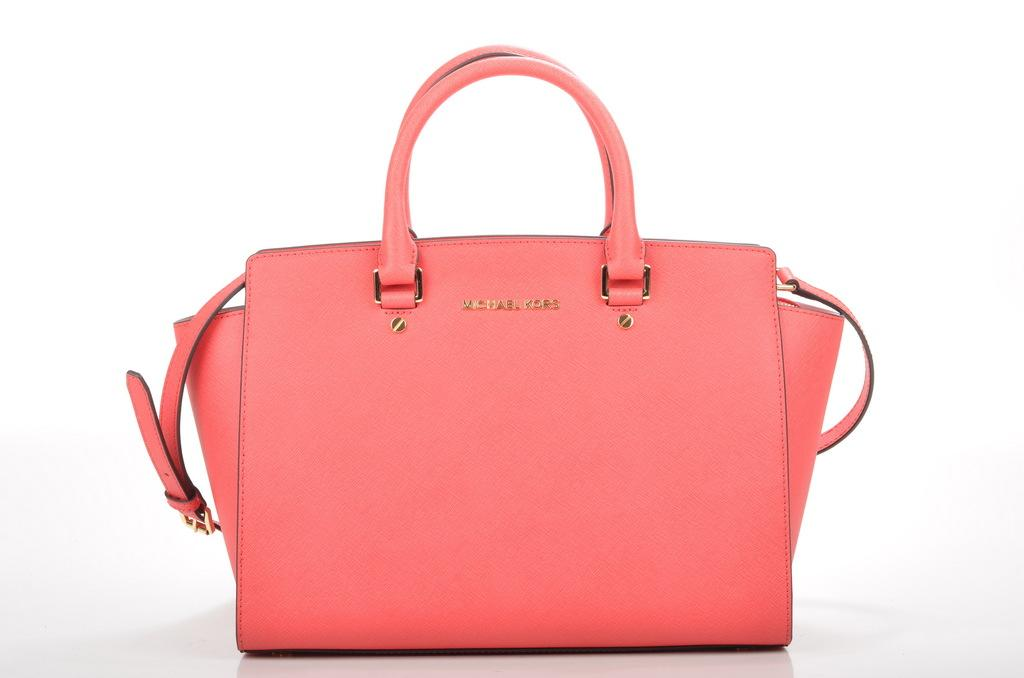What object can be seen in the picture? There is a bag in the picture. What is the color of the bag? The bag is pink in color. What feature does the bag have for carrying purposes? The bag has a handle. What additional feature does the bag have? The bag has a belt. What type of butter is being used to make the bag in the image? There is no butter present in the image, and the bag is not made of any butter-related material. 